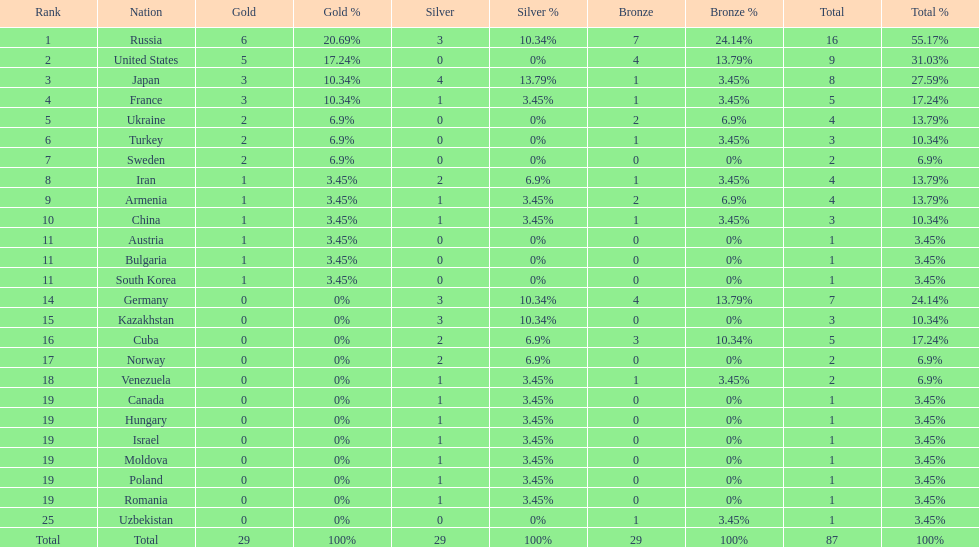How many combined gold medals did japan and france win? 6. 